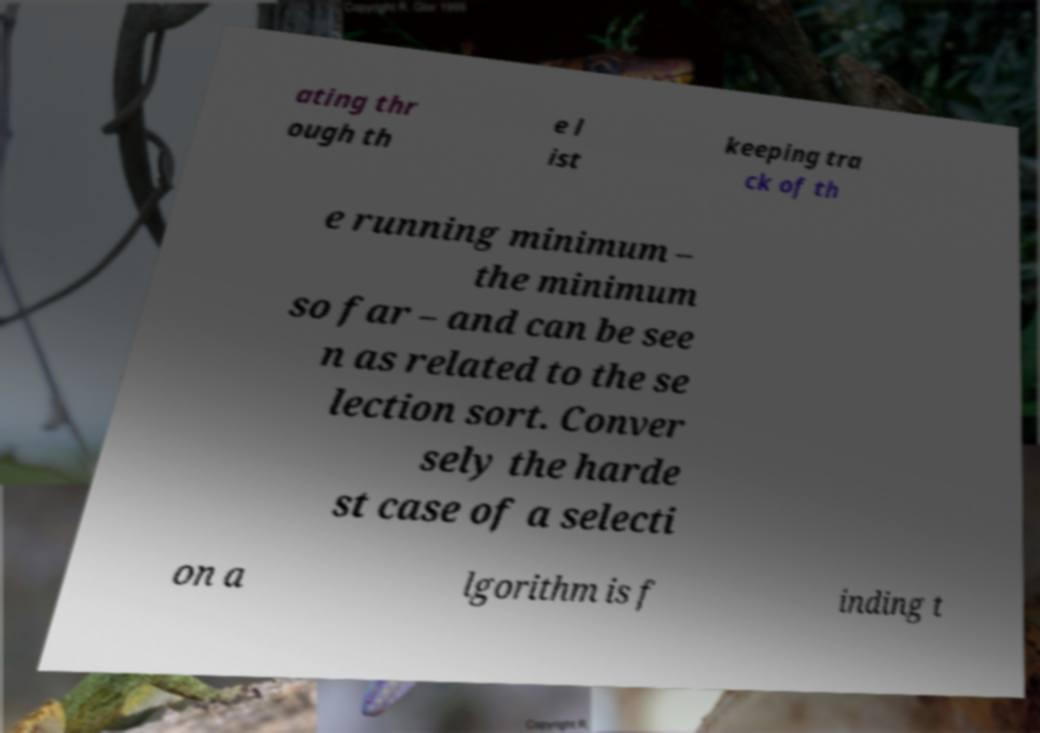What messages or text are displayed in this image? I need them in a readable, typed format. ating thr ough th e l ist keeping tra ck of th e running minimum – the minimum so far – and can be see n as related to the se lection sort. Conver sely the harde st case of a selecti on a lgorithm is f inding t 